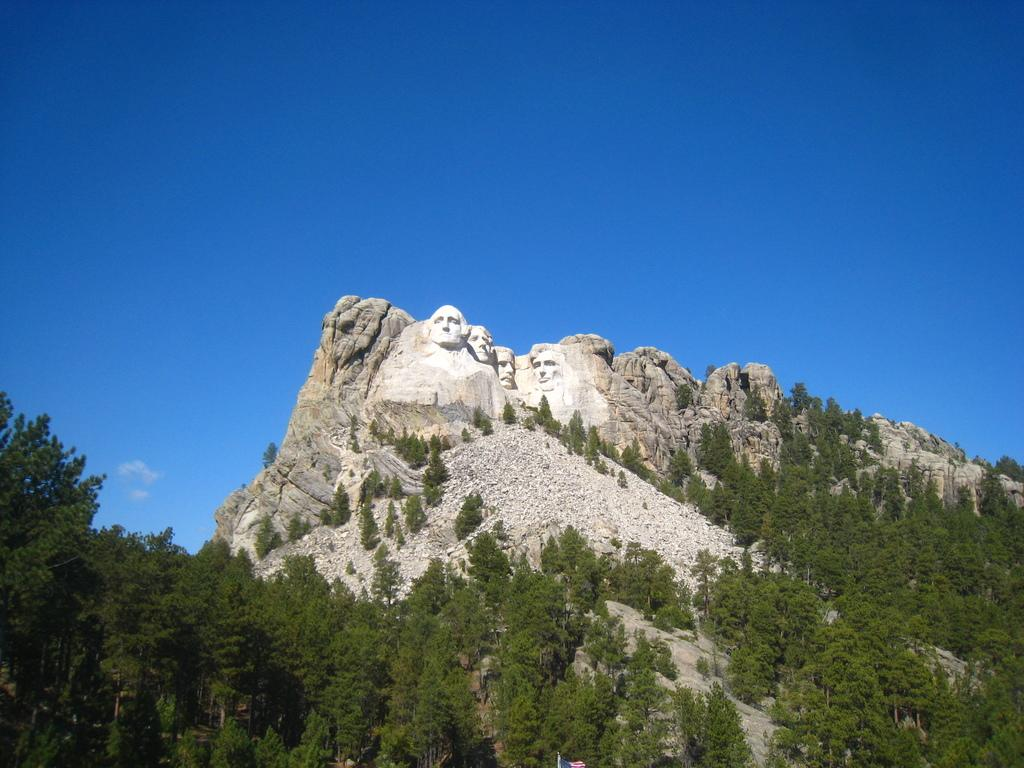What type of vegetation can be seen in the image? There are trees in the image. What is located on the hill in the middle of the image? There are sculptures on a hill in the middle of the image. What is visible at the top of the image? The sky is visible at the top of the image. What type of silver material is used to create the scarecrow in the image? There is no scarecrow present in the image; it features trees and sculptures on a hill. What is the interest rate for the loan depicted in the image? There is no loan or interest rate mentioned in the image; it only shows trees, sculptures, and the sky. 